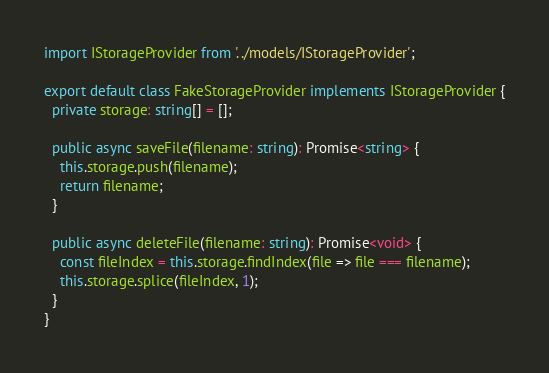Convert code to text. <code><loc_0><loc_0><loc_500><loc_500><_TypeScript_>import IStorageProvider from '../models/IStorageProvider';

export default class FakeStorageProvider implements IStorageProvider {
  private storage: string[] = [];

  public async saveFile(filename: string): Promise<string> {
    this.storage.push(filename);
    return filename;
  }

  public async deleteFile(filename: string): Promise<void> {
    const fileIndex = this.storage.findIndex(file => file === filename);
    this.storage.splice(fileIndex, 1);
  }
}
</code> 